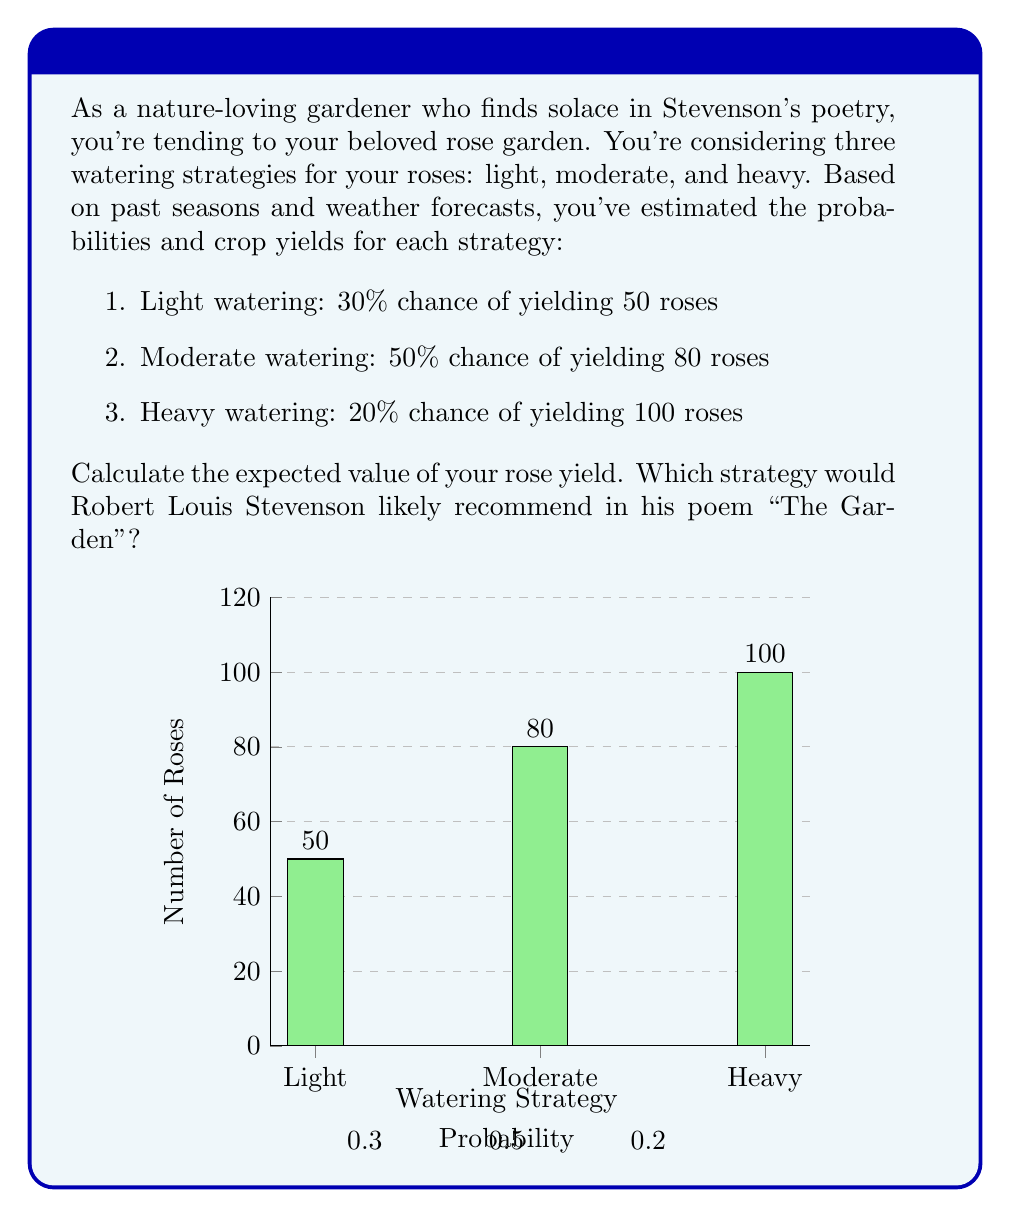Could you help me with this problem? To calculate the expected value of the rose yield, we need to multiply each possible outcome by its probability and then sum these products. Let's break it down step-by-step:

1. For light watering:
   Expected yield = $0.30 \times 50 = 15$ roses

2. For moderate watering:
   Expected yield = $0.50 \times 80 = 40$ roses

3. For heavy watering:
   Expected yield = $0.20 \times 100 = 20$ roses

Now, we sum these expected yields:

$$\text{Total Expected Value} = 15 + 40 + 20 = 75\text{ roses}$$

To determine which strategy Stevenson might recommend in "The Garden," we should consider his love for nature and balance. The moderate watering strategy yields the highest individual expected value (40 roses) and represents a balanced approach, which aligns with the theme of harmony often found in Stevenson's nature poetry.
Answer: 75 roses; Moderate watering 